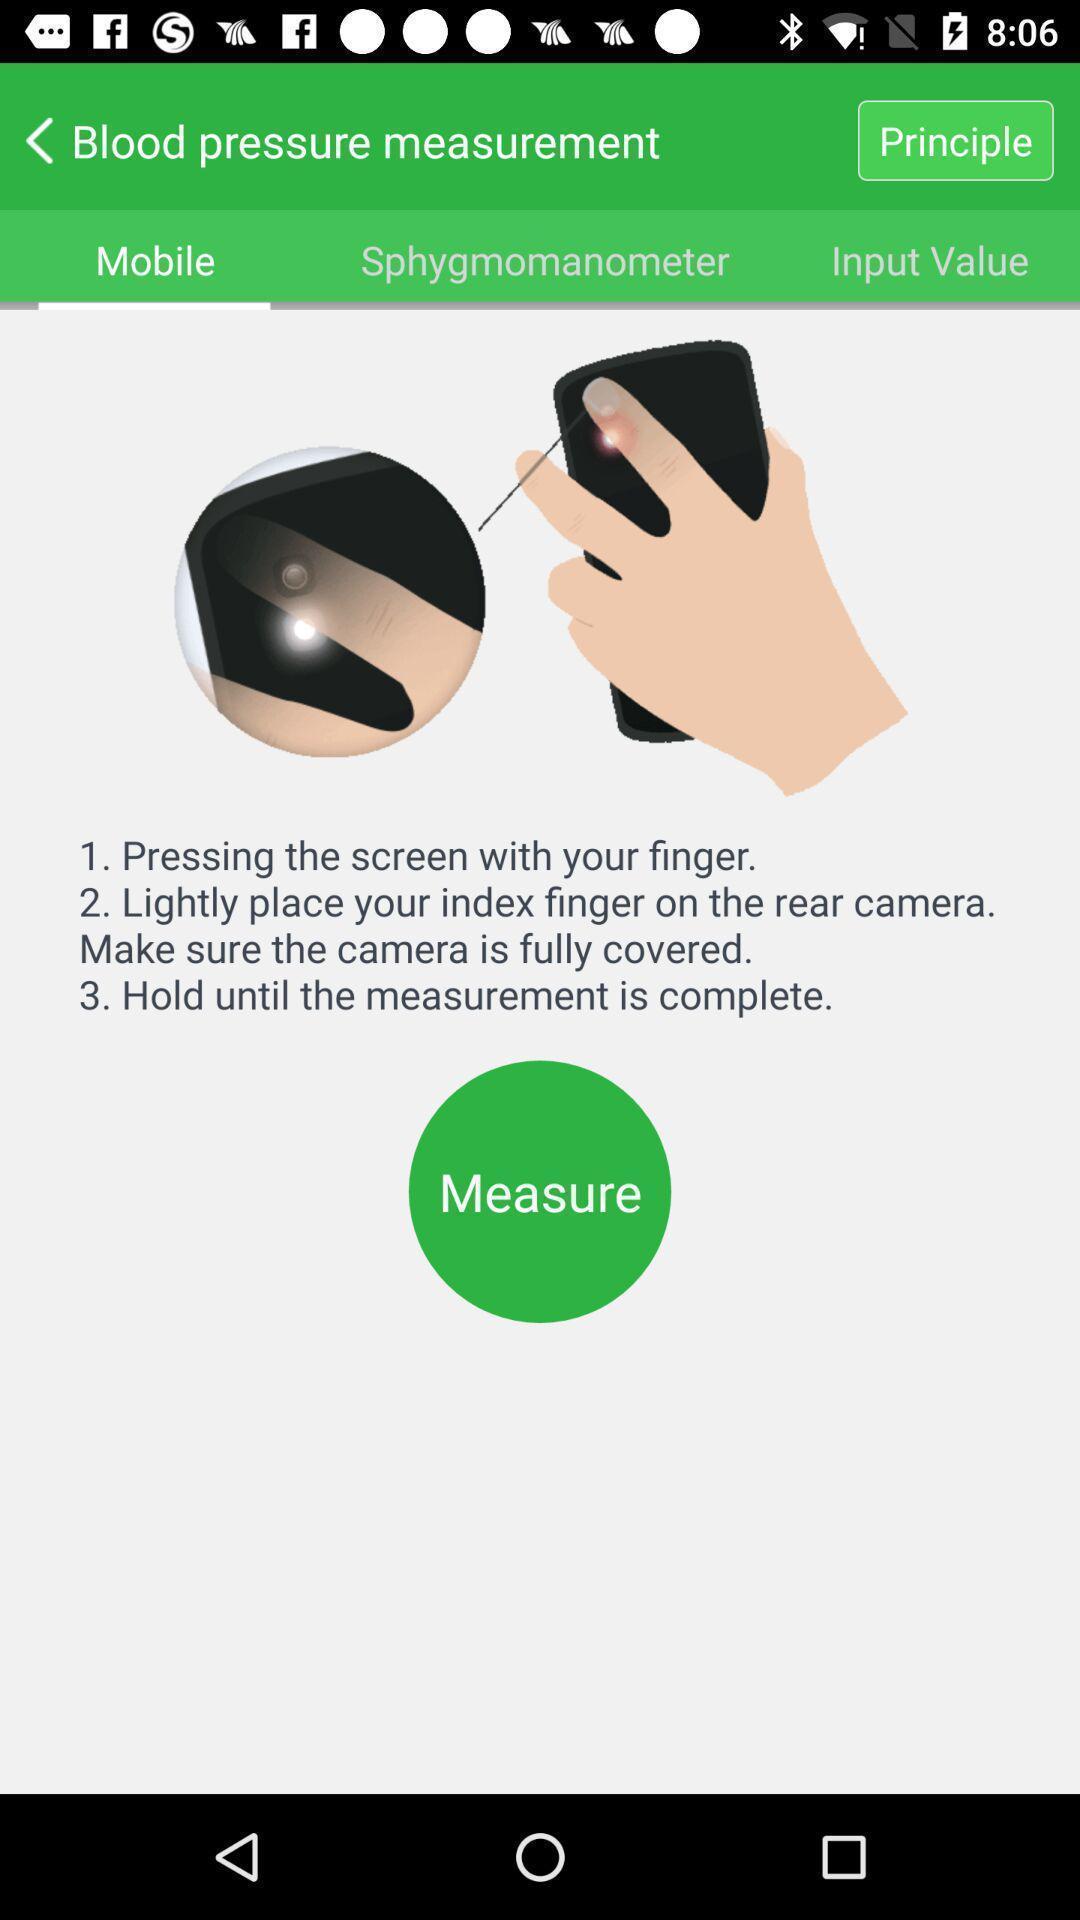Provide a textual representation of this image. Screen showing instructions to measure bp. 